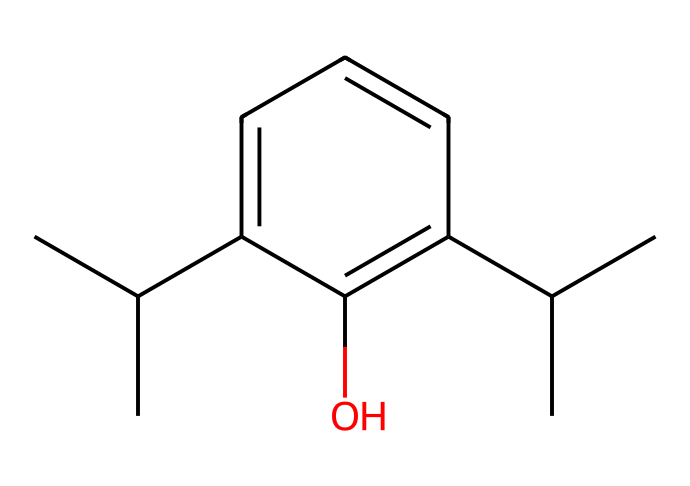What is the molecular formula of propofol? To determine the molecular formula, count the number of each type of atom in the chemical structure. The structure shows 12 carbon atoms, 18 hydrogen atoms, and 1 oxygen atom, leading to the molecular formula C12H18O.
Answer: C12H18O How many hydroxyl (–OH) groups are present in propofol? In the given structure, there is one –OH group attached to the aromatic ring, which indicates the presence of a single hydroxyl group.
Answer: 1 How many rings are present in the structure of propofol? An examination of the structure reveals that it contains one aromatic ring, which is a feature of phenolic compounds. Thus, there is one ring in the molecular structure.
Answer: 1 What type of compound is propofol? Based on the presence of the hydroxyl group attached to the aromatic ring in the structure, propofol is categorized as a phenolic compound.
Answer: phenolic When comparing propofol to typical phenols, how does propofol's substituents affect its properties? Propofol has two isopropyl groups that provide hydrophobic character, influencing its lipophilicity, which contrasts with simpler phenols that may have fewer or no substituents. This increased lipophilicity often enhances the drug's potency and effectiveness as an anesthetic.
Answer: increased lipophilicity What role does the aromatic ring play in propofol's chemical behavior? The aromatic ring stabilizes the molecule through delocalized pi electrons, contributing to its chemical properties and reactivity, characteristic of phenols, which can influence how propofol interacts with biological targets like receptors or enzymes.
Answer: stabilizes the molecule What could be a potential hazard of propofol due to its structure? Given the presence of a hydroxyl group and the hydrophobic isopropyl groups, propofol may interact with biological membranes and proteins, which can lead to potential side effects if misused, such as respiratory depression or hypotension during its anesthetic application.
Answer: respiratory depression 